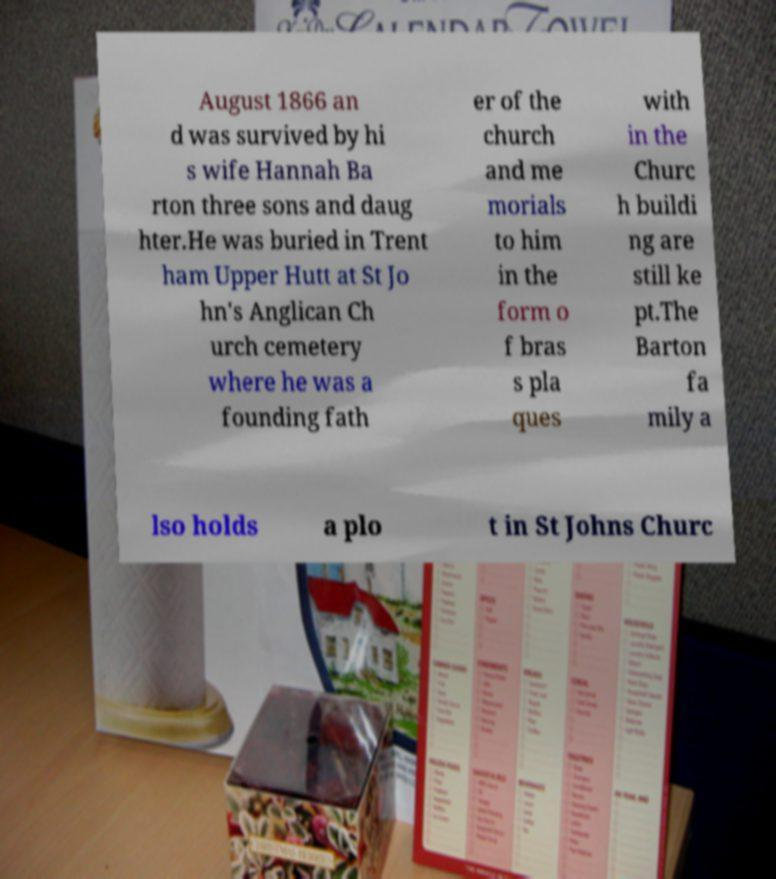What messages or text are displayed in this image? I need them in a readable, typed format. August 1866 an d was survived by hi s wife Hannah Ba rton three sons and daug hter.He was buried in Trent ham Upper Hutt at St Jo hn's Anglican Ch urch cemetery where he was a founding fath er of the church and me morials to him in the form o f bras s pla ques with in the Churc h buildi ng are still ke pt.The Barton fa mily a lso holds a plo t in St Johns Churc 